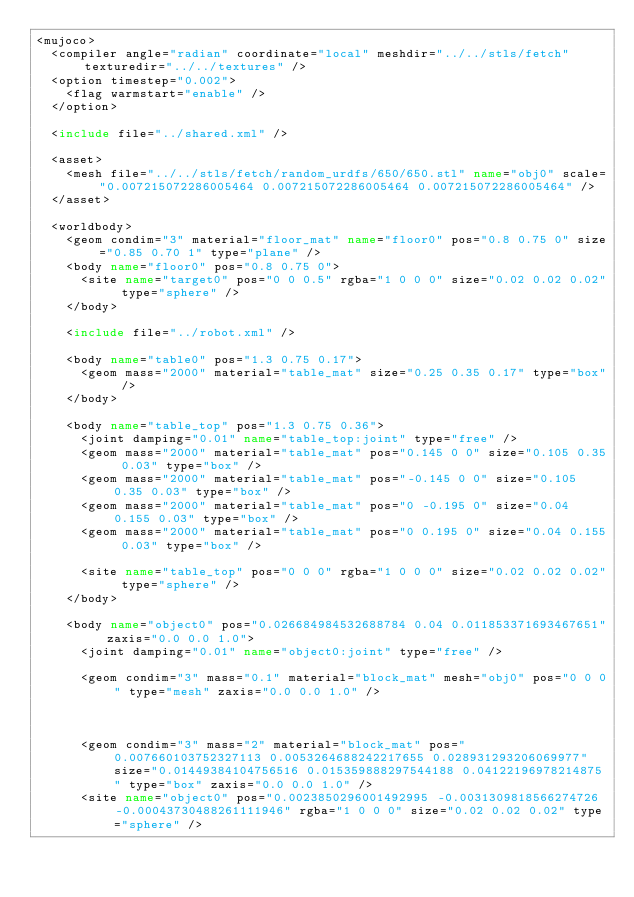<code> <loc_0><loc_0><loc_500><loc_500><_XML_><mujoco>
	<compiler angle="radian" coordinate="local" meshdir="../../stls/fetch" texturedir="../../textures" />
	<option timestep="0.002">
		<flag warmstart="enable" />
	</option>

	<include file="../shared.xml" />

	<asset>
		<mesh file="../../stls/fetch/random_urdfs/650/650.stl" name="obj0" scale="0.007215072286005464 0.007215072286005464 0.007215072286005464" />
	</asset>

	<worldbody>
		<geom condim="3" material="floor_mat" name="floor0" pos="0.8 0.75 0" size="0.85 0.70 1" type="plane" />
		<body name="floor0" pos="0.8 0.75 0">
			<site name="target0" pos="0 0 0.5" rgba="1 0 0 0" size="0.02 0.02 0.02" type="sphere" />
		</body>

		<include file="../robot.xml" />

		<body name="table0" pos="1.3 0.75 0.17">
			<geom mass="2000" material="table_mat" size="0.25 0.35 0.17" type="box" />
		</body>

		<body name="table_top" pos="1.3 0.75 0.36">
			<joint damping="0.01" name="table_top:joint" type="free" />
			<geom mass="2000" material="table_mat" pos="0.145 0 0" size="0.105 0.35 0.03" type="box" />
			<geom mass="2000" material="table_mat" pos="-0.145 0 0" size="0.105 0.35 0.03" type="box" />
			<geom mass="2000" material="table_mat" pos="0 -0.195 0" size="0.04 0.155 0.03" type="box" />
			<geom mass="2000" material="table_mat" pos="0 0.195 0" size="0.04 0.155 0.03" type="box" />

			<site name="table_top" pos="0 0 0" rgba="1 0 0 0" size="0.02 0.02 0.02" type="sphere" />
		</body>

		<body name="object0" pos="0.026684984532688784 0.04 0.011853371693467651" zaxis="0.0 0.0 1.0">
			<joint damping="0.01" name="object0:joint" type="free" />
			
			<geom condim="3" mass="0.1" material="block_mat" mesh="obj0" pos="0 0 0" type="mesh" zaxis="0.0 0.0 1.0" />
			
			
			
			<geom condim="3" mass="2" material="block_mat" pos="0.007660103752327113 0.0053264688242217655 0.028931293206069977" size="0.01449384104756516 0.015359888297544188 0.04122196978214875" type="box" zaxis="0.0 0.0 1.0" />
			<site name="object0" pos="0.0023850296001492995 -0.0031309818566274726 -0.00043730488261111946" rgba="1 0 0 0" size="0.02 0.02 0.02" type="sphere" /></code> 